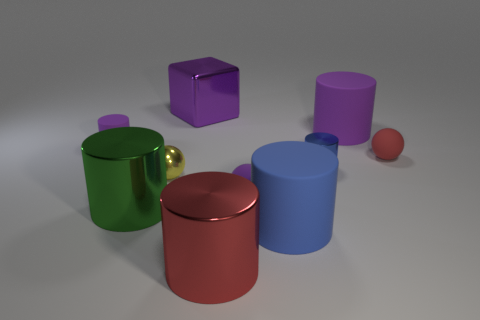Could the arrangement of the objects in this image represent some sort of pattern or have any particular meaning? While the arrangement of objects in this image may not convey a clear pattern, it seems to feature varying geometric shapes and colors that could symbolize diversity or individuality. Each object stands separate from the others, which might imply a theme of uniqueness or independence. 